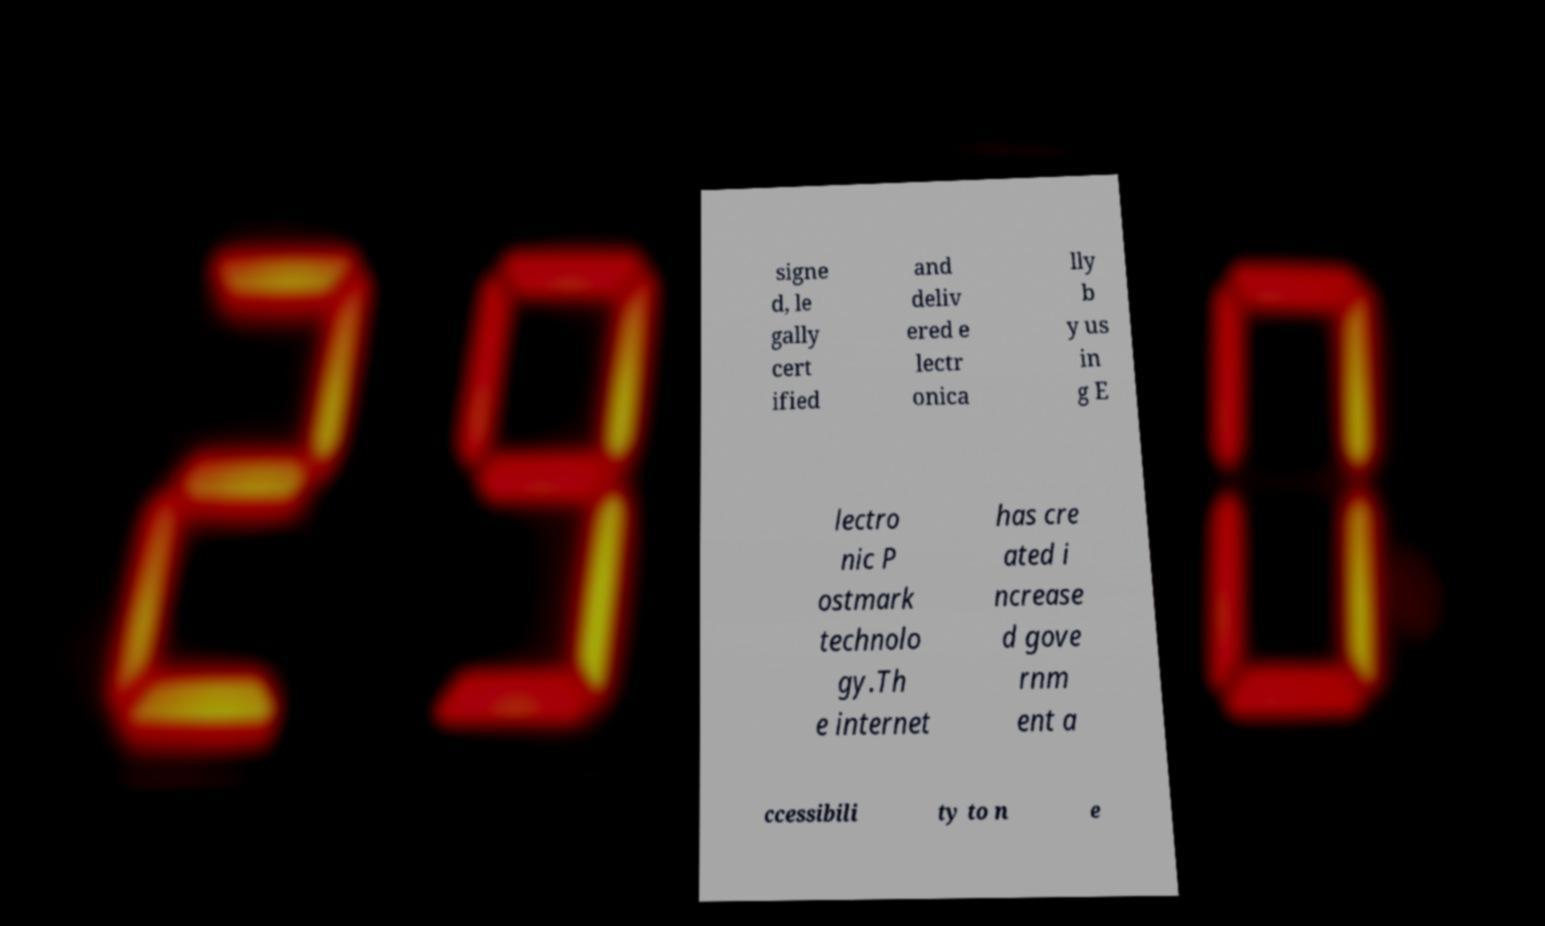Can you accurately transcribe the text from the provided image for me? signe d, le gally cert ified and deliv ered e lectr onica lly b y us in g E lectro nic P ostmark technolo gy.Th e internet has cre ated i ncrease d gove rnm ent a ccessibili ty to n e 